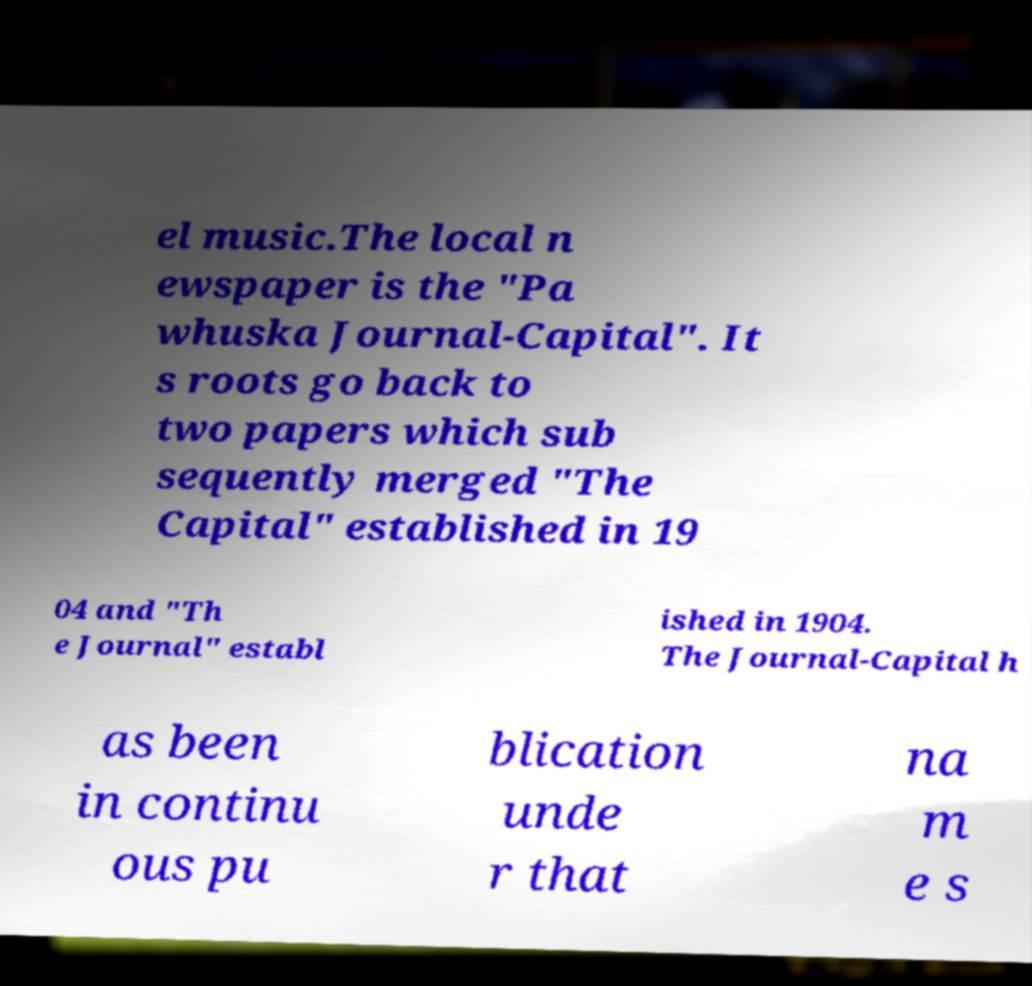Could you assist in decoding the text presented in this image and type it out clearly? el music.The local n ewspaper is the "Pa whuska Journal-Capital". It s roots go back to two papers which sub sequently merged "The Capital" established in 19 04 and "Th e Journal" establ ished in 1904. The Journal-Capital h as been in continu ous pu blication unde r that na m e s 